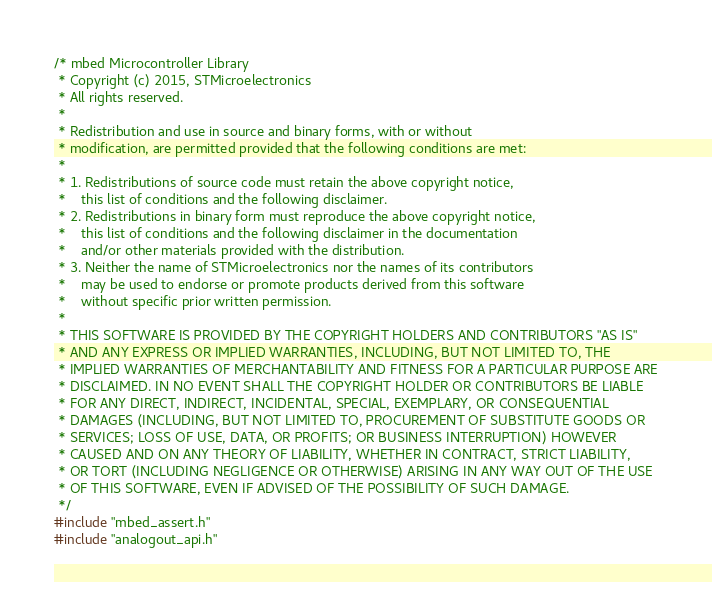Convert code to text. <code><loc_0><loc_0><loc_500><loc_500><_C_>/* mbed Microcontroller Library
 * Copyright (c) 2015, STMicroelectronics
 * All rights reserved.
 *
 * Redistribution and use in source and binary forms, with or without
 * modification, are permitted provided that the following conditions are met:
 *
 * 1. Redistributions of source code must retain the above copyright notice,
 *    this list of conditions and the following disclaimer.
 * 2. Redistributions in binary form must reproduce the above copyright notice,
 *    this list of conditions and the following disclaimer in the documentation
 *    and/or other materials provided with the distribution.
 * 3. Neither the name of STMicroelectronics nor the names of its contributors
 *    may be used to endorse or promote products derived from this software
 *    without specific prior written permission.
 *
 * THIS SOFTWARE IS PROVIDED BY THE COPYRIGHT HOLDERS AND CONTRIBUTORS "AS IS"
 * AND ANY EXPRESS OR IMPLIED WARRANTIES, INCLUDING, BUT NOT LIMITED TO, THE
 * IMPLIED WARRANTIES OF MERCHANTABILITY AND FITNESS FOR A PARTICULAR PURPOSE ARE
 * DISCLAIMED. IN NO EVENT SHALL THE COPYRIGHT HOLDER OR CONTRIBUTORS BE LIABLE
 * FOR ANY DIRECT, INDIRECT, INCIDENTAL, SPECIAL, EXEMPLARY, OR CONSEQUENTIAL
 * DAMAGES (INCLUDING, BUT NOT LIMITED TO, PROCUREMENT OF SUBSTITUTE GOODS OR
 * SERVICES; LOSS OF USE, DATA, OR PROFITS; OR BUSINESS INTERRUPTION) HOWEVER
 * CAUSED AND ON ANY THEORY OF LIABILITY, WHETHER IN CONTRACT, STRICT LIABILITY,
 * OR TORT (INCLUDING NEGLIGENCE OR OTHERWISE) ARISING IN ANY WAY OUT OF THE USE
 * OF THIS SOFTWARE, EVEN IF ADVISED OF THE POSSIBILITY OF SUCH DAMAGE.
 */
#include "mbed_assert.h"
#include "analogout_api.h"
</code> 